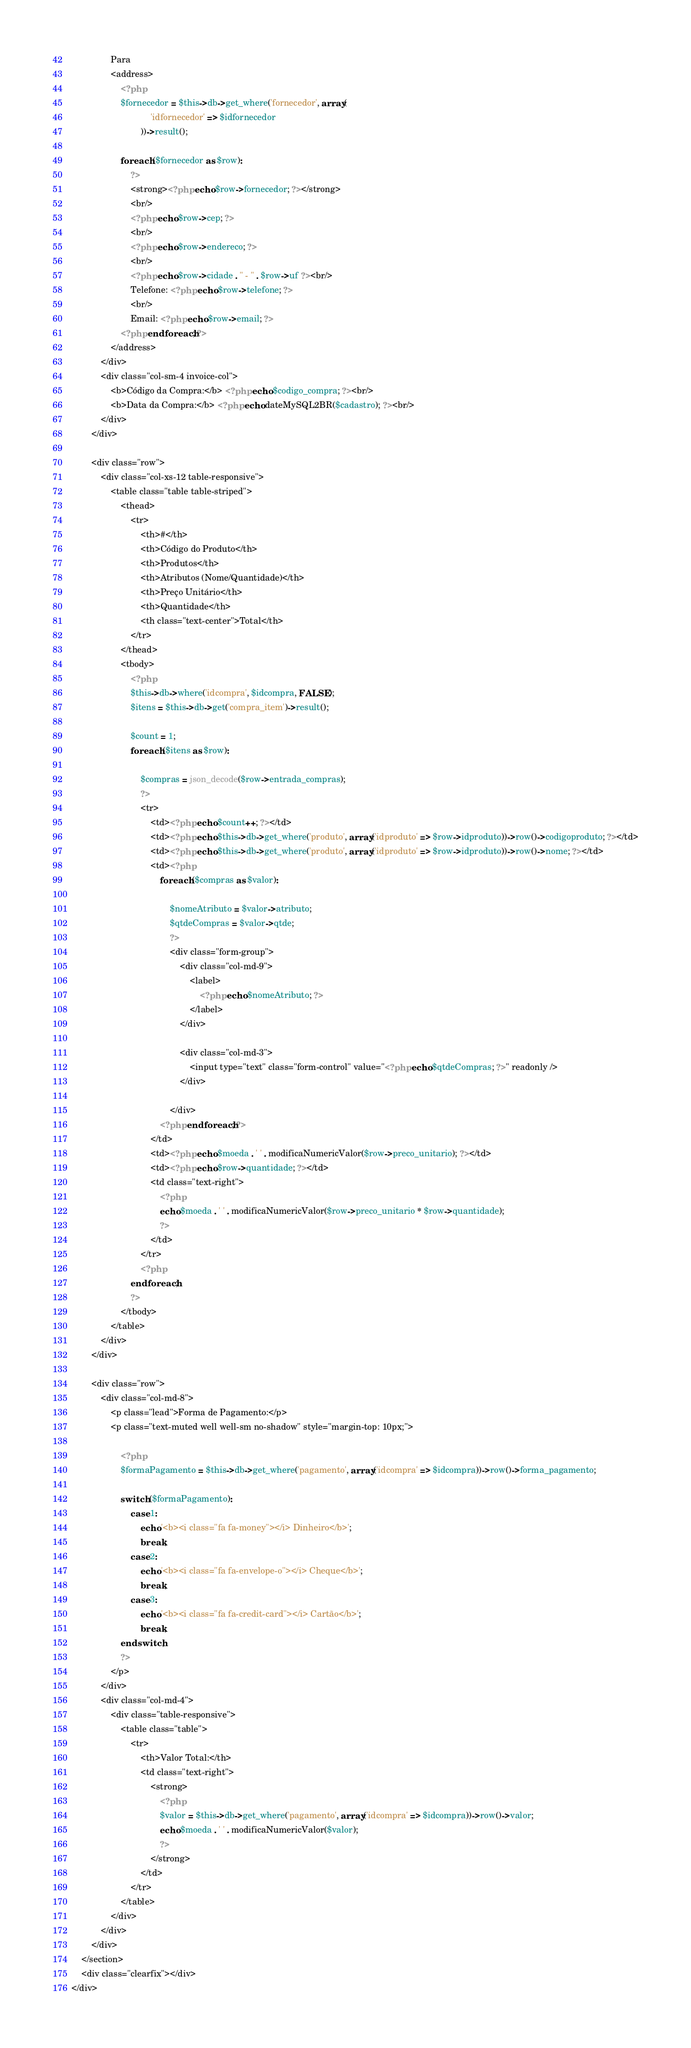<code> <loc_0><loc_0><loc_500><loc_500><_PHP_>                Para
                <address>
                    <?php
                    $fornecedor = $this->db->get_where('fornecedor', array(
                                'idfornecedor' => $idfornecedor
                            ))->result();

                    foreach ($fornecedor as $row):
                        ?>
                        <strong><?php echo $row->fornecedor; ?></strong>
                        <br/>
                        <?php echo $row->cep; ?>
                        <br/>
                        <?php echo $row->endereco; ?>
                        <br/>
                        <?php echo $row->cidade . " - " . $row->uf ?><br/>
                        Telefone: <?php echo $row->telefone; ?>
                        <br/>
                        Email: <?php echo $row->email; ?>
                    <?php endforeach; ?>
                </address>
            </div>
            <div class="col-sm-4 invoice-col">
                <b>Código da Compra:</b> <?php echo $codigo_compra; ?><br/>
                <b>Data da Compra:</b> <?php echo dateMySQL2BR($cadastro); ?><br/>
            </div>
        </div>

        <div class="row">
            <div class="col-xs-12 table-responsive">
                <table class="table table-striped">
                    <thead>
                        <tr>
                            <th>#</th>
                            <th>Código do Produto</th>
                            <th>Produtos</th>
                            <th>Atributos (Nome/Quantidade)</th>
                            <th>Preço Unitário</th>
                            <th>Quantidade</th>
                            <th class="text-center">Total</th>
                        </tr>
                    </thead>
                    <tbody>
                        <?php
                        $this->db->where('idcompra', $idcompra, FALSE);
                        $itens = $this->db->get('compra_item')->result();

                        $count = 1;
                        foreach ($itens as $row):

                            $compras = json_decode($row->entrada_compras);
                            ?>
                            <tr>
                                <td><?php echo $count++; ?></td>
                                <td><?php echo $this->db->get_where('produto', array('idproduto' => $row->idproduto))->row()->codigoproduto; ?></td>
                                <td><?php echo $this->db->get_where('produto', array('idproduto' => $row->idproduto))->row()->nome; ?></td>
                                <td><?php
                                    foreach ($compras as $valor):

                                        $nomeAtributo = $valor->atributo;
                                        $qtdeCompras = $valor->qtde;
                                        ?>
                                        <div class="form-group">
                                            <div class="col-md-9">
                                                <label>
                                                    <?php echo $nomeAtributo; ?>
                                                </label>
                                            </div>

                                            <div class="col-md-3">
                                                <input type="text" class="form-control" value="<?php echo $qtdeCompras; ?>" readonly />
                                            </div>

                                        </div>
                                    <?php endforeach; ?>
                                </td>
                                <td><?php echo $moeda . ' ' . modificaNumericValor($row->preco_unitario); ?></td>
                                <td><?php echo $row->quantidade; ?></td>
                                <td class="text-right">
                                    <?php
                                    echo $moeda . ' ' . modificaNumericValor($row->preco_unitario * $row->quantidade);
                                    ?>
                                </td>
                            </tr>
                            <?php
                        endforeach;
                        ?>
                    </tbody>
                </table>
            </div>
        </div>

        <div class="row">
            <div class="col-md-8">
                <p class="lead">Forma de Pagamento:</p>
                <p class="text-muted well well-sm no-shadow" style="margin-top: 10px;">

                    <?php
                    $formaPagamento = $this->db->get_where('pagamento', array('idcompra' => $idcompra))->row()->forma_pagamento;

                    switch ($formaPagamento):
                        case 1:
                            echo '<b><i class="fa fa-money"></i> Dinheiro</b>';
                            break;
                        case 2:
                            echo '<b><i class="fa fa-envelope-o"></i> Cheque</b>';
                            break;
                        case 3:
                            echo '<b><i class="fa fa-credit-card"></i> Cartão</b>';
                            break;
                    endswitch;
                    ?>
                </p>
            </div>
            <div class="col-md-4">
                <div class="table-responsive">
                    <table class="table">
                        <tr>
                            <th>Valor Total:</th>
                            <td class="text-right">
                                <strong>
                                    <?php
                                    $valor = $this->db->get_where('pagamento', array('idcompra' => $idcompra))->row()->valor;
                                    echo $moeda . ' ' . modificaNumericValor($valor);
                                    ?>
                                </strong>
                            </td>
                        </tr>
                    </table>
                </div>
            </div>
        </div>
    </section>
    <div class="clearfix"></div>
</div></code> 